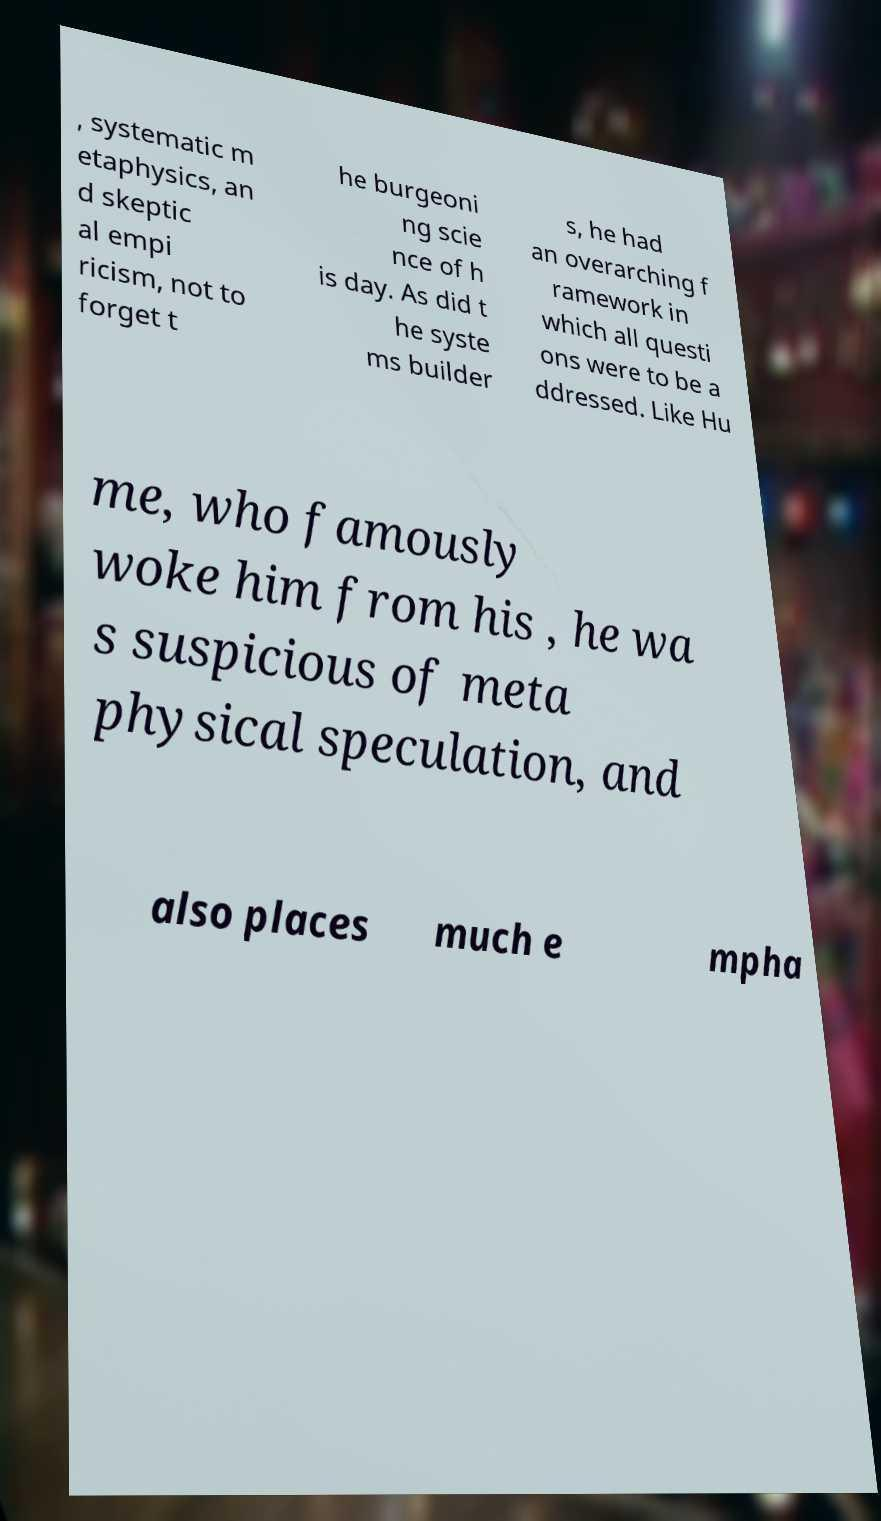Could you extract and type out the text from this image? , systematic m etaphysics, an d skeptic al empi ricism, not to forget t he burgeoni ng scie nce of h is day. As did t he syste ms builder s, he had an overarching f ramework in which all questi ons were to be a ddressed. Like Hu me, who famously woke him from his , he wa s suspicious of meta physical speculation, and also places much e mpha 